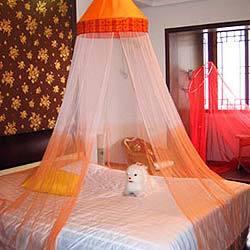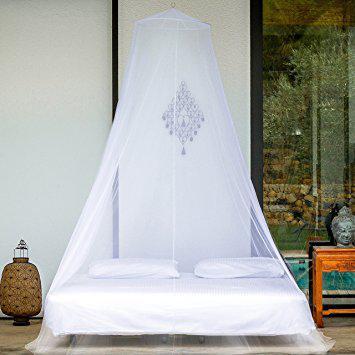The first image is the image on the left, the second image is the image on the right. For the images shown, is this caption "All images show a bed covered by a cone-shaped canopy." true? Answer yes or no. Yes. The first image is the image on the left, the second image is the image on the right. Considering the images on both sides, is "All bed nets are hanging from a central hook above the bed and draped outward." valid? Answer yes or no. Yes. 